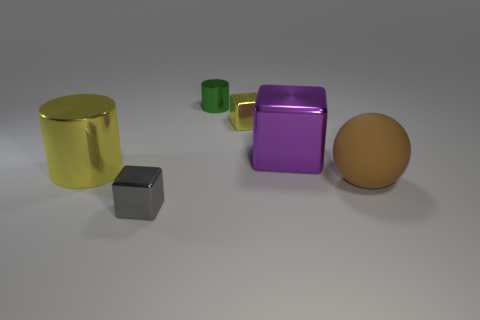There is a big cylinder; is it the same color as the tiny shiny block that is to the right of the small green metal thing?
Offer a terse response. Yes. What material is the large thing in front of the cylinder that is in front of the purple thing?
Provide a short and direct response. Rubber. How many blocks have the same color as the big shiny cylinder?
Offer a terse response. 1. There is a metallic block that is behind the block that is on the right side of the tiny yellow block that is left of the purple block; what is its color?
Your response must be concise. Yellow. How many metallic things are both in front of the matte ball and behind the big sphere?
Your answer should be compact. 0. There is a metal thing that is on the left side of the gray block; does it have the same color as the tiny cube that is behind the purple cube?
Offer a terse response. Yes. Is there anything else that is the same material as the big sphere?
Make the answer very short. No. There is a yellow object that is the same shape as the purple thing; what is its size?
Keep it short and to the point. Small. There is a purple thing; are there any small gray cubes in front of it?
Offer a terse response. Yes. Are there an equal number of big matte spheres on the left side of the small gray block and yellow cubes?
Give a very brief answer. No. 